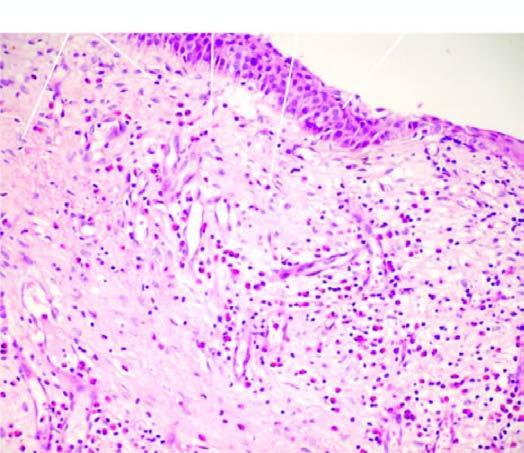s 2 and 3 covered partly by respiratory and partly by squamous metaplastic epithelium?
Answer the question using a single word or phrase. No 